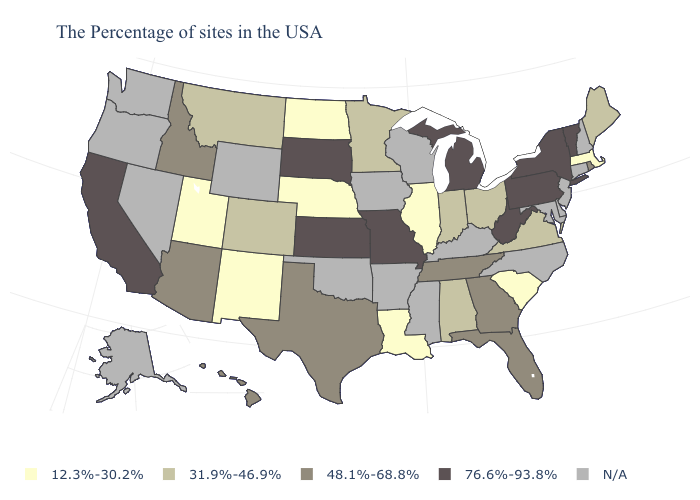Among the states that border North Dakota , does South Dakota have the lowest value?
Keep it brief. No. What is the value of Louisiana?
Short answer required. 12.3%-30.2%. Does California have the highest value in the USA?
Answer briefly. Yes. What is the value of Mississippi?
Concise answer only. N/A. Among the states that border New Mexico , which have the highest value?
Concise answer only. Texas, Arizona. Name the states that have a value in the range 48.1%-68.8%?
Short answer required. Rhode Island, Florida, Georgia, Tennessee, Texas, Arizona, Idaho, Hawaii. Which states have the lowest value in the USA?
Concise answer only. Massachusetts, South Carolina, Illinois, Louisiana, Nebraska, North Dakota, New Mexico, Utah. Does the map have missing data?
Keep it brief. Yes. What is the value of West Virginia?
Short answer required. 76.6%-93.8%. What is the value of Illinois?
Give a very brief answer. 12.3%-30.2%. Name the states that have a value in the range 31.9%-46.9%?
Concise answer only. Maine, Virginia, Ohio, Indiana, Alabama, Minnesota, Colorado, Montana. Name the states that have a value in the range 31.9%-46.9%?
Be succinct. Maine, Virginia, Ohio, Indiana, Alabama, Minnesota, Colorado, Montana. Does the map have missing data?
Quick response, please. Yes. What is the value of Nebraska?
Write a very short answer. 12.3%-30.2%. What is the highest value in the South ?
Be succinct. 76.6%-93.8%. 